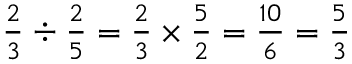<formula> <loc_0><loc_0><loc_500><loc_500>{ \frac { 2 } { 3 } } \div { \frac { 2 } { 5 } } = { \frac { 2 } { 3 } } \times { \frac { 5 } { 2 } } = { \frac { 1 0 } { 6 } } = { \frac { 5 } { 3 } }</formula> 